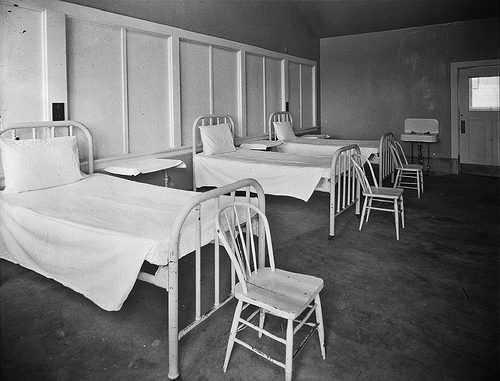What could this room tell us about medical care during the time it was used? Given the room's minimalistic setting, it suggests that medical care in that era focused more on basic functionality rather than patient comfort. Simple metal beds, bare walls, and the absence of advanced medical equipment imply that medical practices were more rudimentary, with an emphasis on practicality and perhaps a lesser degree of patient-centered care. 